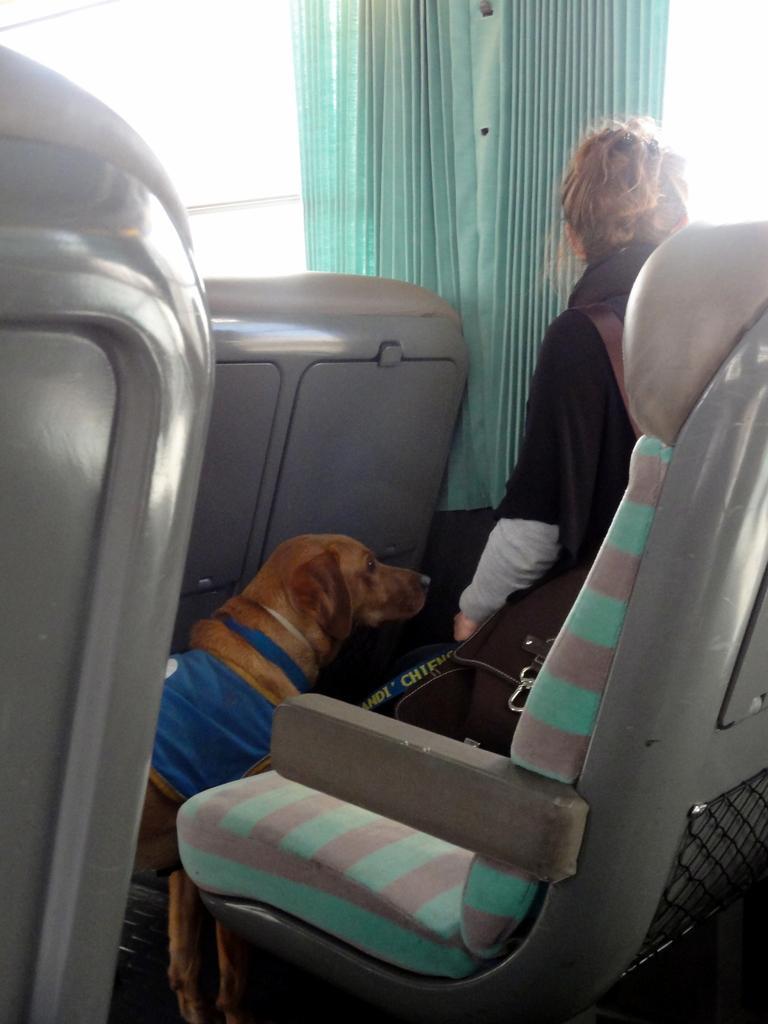Can you describe this image briefly? This is an inside view of a vehicle. On the right side there is a person sitting on a seat. Beside this person there is a bag and also there is a dog. At the top of the image I can see a curtain to the window. 